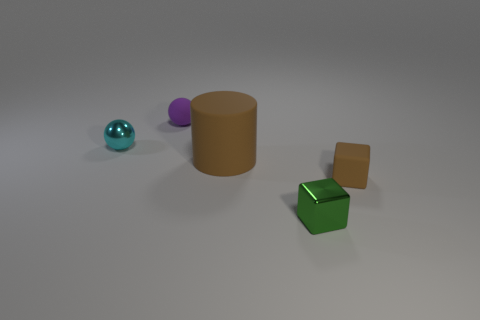Add 5 tiny green spheres. How many objects exist? 10 Subtract all cubes. How many objects are left? 3 Add 3 small metallic blocks. How many small metallic blocks exist? 4 Subtract 1 cyan balls. How many objects are left? 4 Subtract all balls. Subtract all tiny metallic balls. How many objects are left? 2 Add 2 small purple balls. How many small purple balls are left? 3 